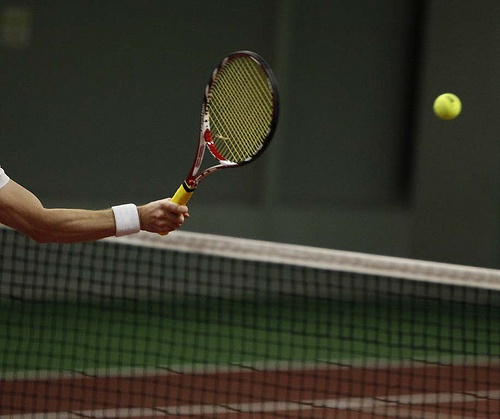Describe the objects in this image and their specific colors. I can see tennis racket in black, olive, and gray tones, people in black, maroon, gray, and tan tones, and sports ball in black, khaki, and olive tones in this image. 